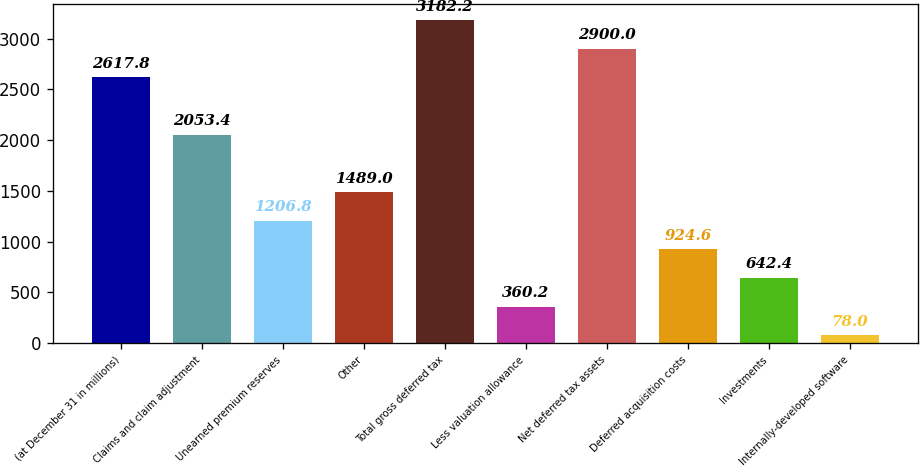Convert chart to OTSL. <chart><loc_0><loc_0><loc_500><loc_500><bar_chart><fcel>(at December 31 in millions)<fcel>Claims and claim adjustment<fcel>Unearned premium reserves<fcel>Other<fcel>Total gross deferred tax<fcel>Less valuation allowance<fcel>Net deferred tax assets<fcel>Deferred acquisition costs<fcel>Investments<fcel>Internally-developed software<nl><fcel>2617.8<fcel>2053.4<fcel>1206.8<fcel>1489<fcel>3182.2<fcel>360.2<fcel>2900<fcel>924.6<fcel>642.4<fcel>78<nl></chart> 